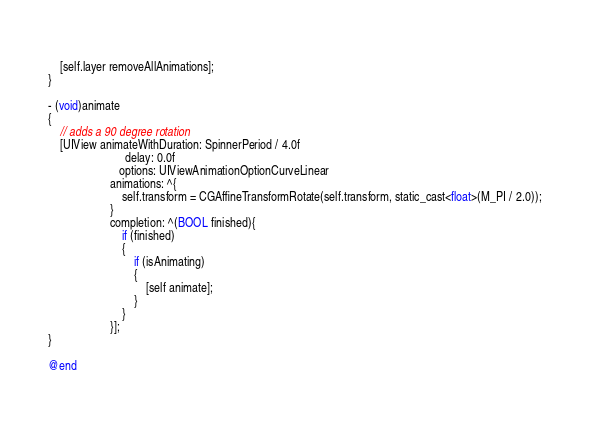Convert code to text. <code><loc_0><loc_0><loc_500><loc_500><_ObjectiveC_>    
    [self.layer removeAllAnimations];
}

- (void)animate
{
    // adds a 90 degree rotation
    [UIView animateWithDuration: SpinnerPeriod / 4.0f
                          delay: 0.0f
                        options: UIViewAnimationOptionCurveLinear
                     animations: ^{
                         self.transform = CGAffineTransformRotate(self.transform, static_cast<float>(M_PI / 2.0));
                     }
                     completion: ^(BOOL finished){
                         if (finished)
                         {
                             if (isAnimating)
                             {
                                 [self animate];
                             }
                         }
                     }];
}

@end
</code> 